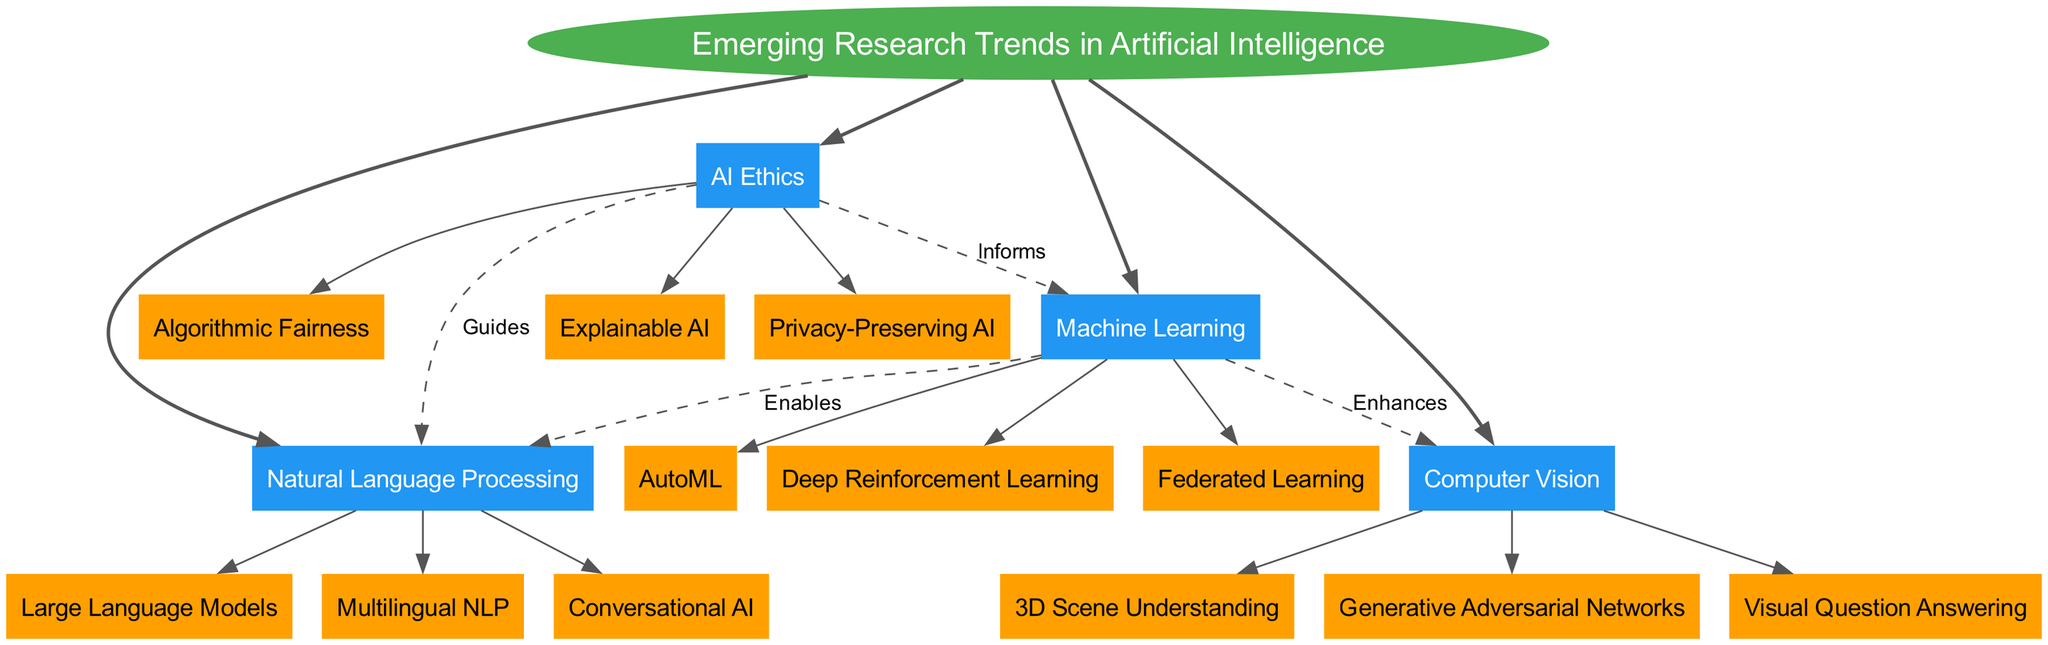What is the central topic of the diagram? The central topic is clearly labeled in an ellipse at the center of the diagram, which states "Emerging Research Trends in Artificial Intelligence."
Answer: Emerging Research Trends in Artificial Intelligence How many main branches are there in the diagram? By counting the main branches depicted around the central topic, we can see there are four branches labeled: Machine Learning, Natural Language Processing, Computer Vision, and AI Ethics.
Answer: 4 What subtopic is connected to "Natural Language Processing" via the label "Enables"? Looking at the connections in the diagram, we can find that "Machine Learning" is connected to "Natural Language Processing" with the label "Enables."
Answer: Machine Learning Which branch directly informs AI Ethics? The diagram shows a dashed connection between "Machine Learning" pointing to "AI Ethics" with the label "Informs." This indicates that "Machine Learning" informs "AI Ethics."
Answer: Machine Learning List the three subtopics under "Computer Vision". By checking the nodes attached to the "Computer Vision" branch, the identified subtopics are: "3D Scene Understanding," "Generative Adversarial Networks," and "Visual Question Answering."
Answer: 3D Scene Understanding, Generative Adversarial Networks, Visual Question Answering Which two branches are linked by the relationship "Guides"? The diagram shows a connection from "AI Ethics" to "Natural Language Processing" labeled "Guides," indicating the guiding relationship specifically between these two branches.
Answer: AI Ethics and Natural Language Processing What type of relationship connects Machine Learning and Computer Vision? The diagram specifies that the relationship between "Machine Learning" and "Computer Vision" is labeled as "Enhances," indicating how Machine Learning positively impacts Computer Vision.
Answer: Enhances How many subtopics are listed under AI Ethics? The "AI Ethics" branch has three subtopics clearly listed, which are "Algorithmic Fairness," "Explainable AI," and "Privacy-Preserving AI," by inspecting the nodes under this branch.
Answer: 3 